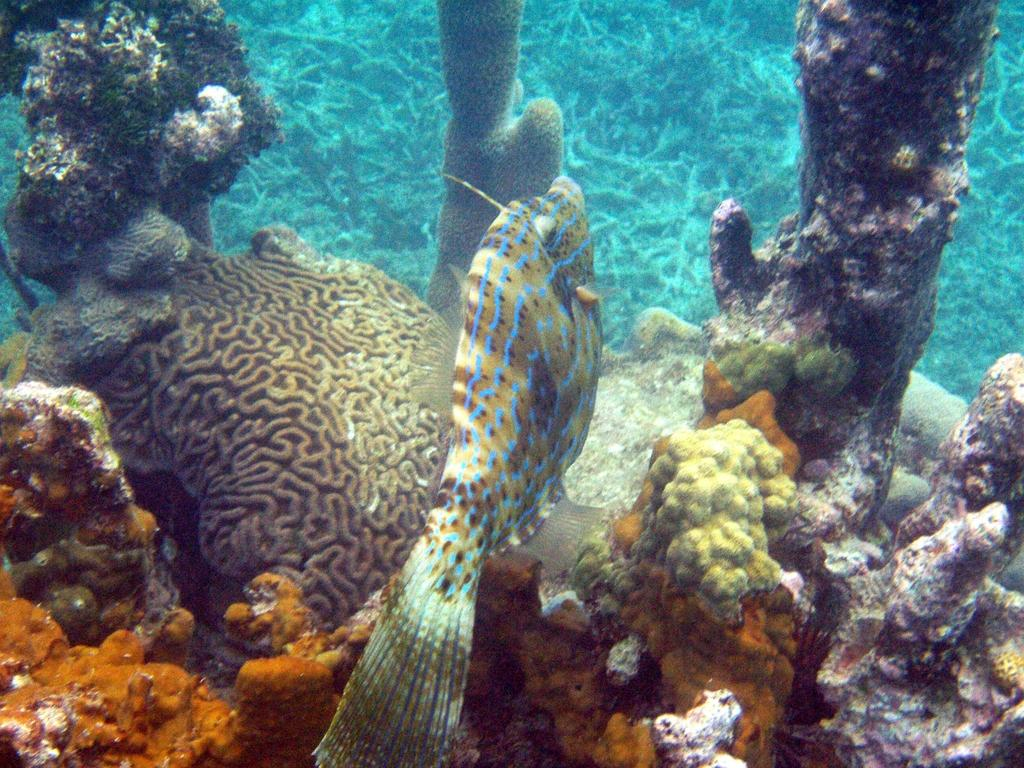What type of animal is in the image? There is a fish in the image. What other marine creature is present in the image? There is a submarine species in the image. What color is the water in the image? The water in the image is blue. Where might this image have been taken? The image may have been taken in the ocean. What type of business is being conducted in the image? There is no indication of any business activity in the image; it features a fish and a submarine species in blue water. Can you see any rifle in the image? There is no rifle present in the image. 